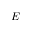<formula> <loc_0><loc_0><loc_500><loc_500>E</formula> 